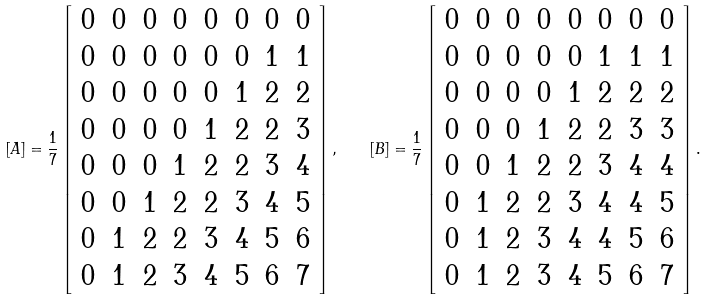Convert formula to latex. <formula><loc_0><loc_0><loc_500><loc_500>[ A ] = \frac { 1 } { 7 } \left [ \begin{array} { c c c c c c c c } 0 & 0 & 0 & 0 & 0 & 0 & 0 & 0 \\ 0 & 0 & 0 & 0 & 0 & 0 & 1 & 1 \\ 0 & 0 & 0 & 0 & 0 & 1 & 2 & 2 \\ 0 & 0 & 0 & 0 & 1 & 2 & 2 & 3 \\ 0 & 0 & 0 & 1 & 2 & 2 & 3 & 4 \\ 0 & 0 & 1 & 2 & 2 & 3 & 4 & 5 \\ 0 & 1 & 2 & 2 & 3 & 4 & 5 & 6 \\ 0 & 1 & 2 & 3 & 4 & 5 & 6 & 7 \\ \end{array} \right ] , \quad [ B ] = \frac { 1 } { 7 } \left [ \begin{array} { c c c c c c c c } 0 & 0 & 0 & 0 & 0 & 0 & 0 & 0 \\ 0 & 0 & 0 & 0 & 0 & 1 & 1 & 1 \\ 0 & 0 & 0 & 0 & 1 & 2 & 2 & 2 \\ 0 & 0 & 0 & 1 & 2 & 2 & 3 & 3 \\ 0 & 0 & 1 & 2 & 2 & 3 & 4 & 4 \\ 0 & 1 & 2 & 2 & 3 & 4 & 4 & 5 \\ 0 & 1 & 2 & 3 & 4 & 4 & 5 & 6 \\ 0 & 1 & 2 & 3 & 4 & 5 & 6 & 7 \\ \end{array} \right ] .</formula> 